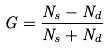Convert formula to latex. <formula><loc_0><loc_0><loc_500><loc_500>G = \frac { N _ { s } - N _ { d } } { N _ { s } + N _ { d } }</formula> 